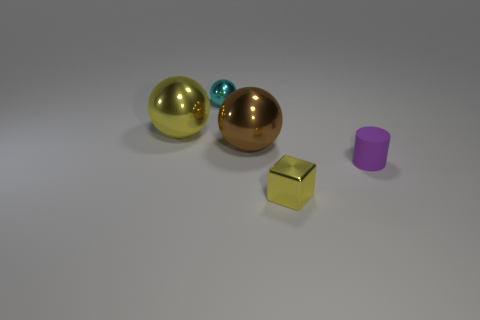The brown shiny thing is what shape?
Offer a terse response. Sphere. How many objects are small yellow shiny cylinders or big metal things?
Your answer should be compact. 2. Does the ball that is on the left side of the cyan sphere have the same color as the thing in front of the purple object?
Offer a terse response. Yes. What number of other things are the same shape as the purple matte object?
Your response must be concise. 0. Are any small cubes visible?
Ensure brevity in your answer.  Yes. What number of things are either big yellow metallic balls or tiny metal objects in front of the matte cylinder?
Your answer should be very brief. 2. Does the shiny object in front of the brown object have the same size as the yellow sphere?
Provide a short and direct response. No. How many other objects are there of the same size as the yellow metallic block?
Your response must be concise. 2. The tiny rubber object has what color?
Provide a short and direct response. Purple. There is a big sphere that is behind the brown metal object; what material is it?
Your response must be concise. Metal. 